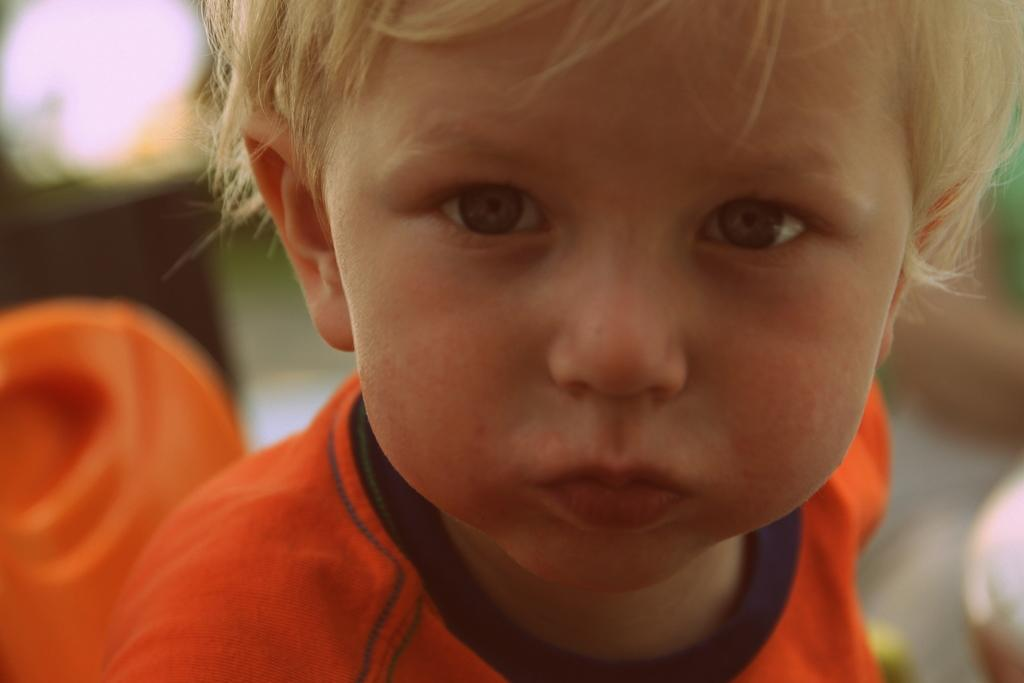What is the main subject of the image? The main subject of the image is a kid. What can be observed about the kid's attire? The kid is wearing clothes. How would you describe the background of the image? The background of the image is blurred. What type of fuel is being used by the stick in the image? There is no stick or fuel present in the image. 